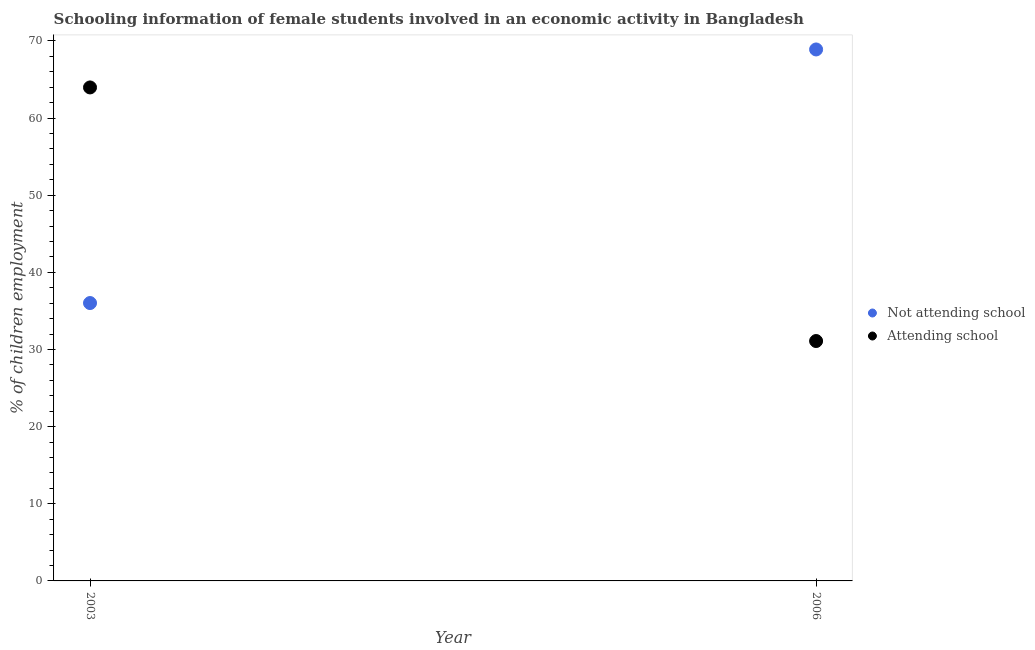How many different coloured dotlines are there?
Your answer should be very brief. 2. Is the number of dotlines equal to the number of legend labels?
Offer a terse response. Yes. What is the percentage of employed females who are not attending school in 2006?
Your answer should be compact. 68.9. Across all years, what is the maximum percentage of employed females who are not attending school?
Give a very brief answer. 68.9. Across all years, what is the minimum percentage of employed females who are not attending school?
Your answer should be compact. 36.02. In which year was the percentage of employed females who are not attending school minimum?
Make the answer very short. 2003. What is the total percentage of employed females who are not attending school in the graph?
Give a very brief answer. 104.92. What is the difference between the percentage of employed females who are not attending school in 2003 and that in 2006?
Provide a short and direct response. -32.88. What is the difference between the percentage of employed females who are not attending school in 2003 and the percentage of employed females who are attending school in 2006?
Your answer should be compact. 4.92. What is the average percentage of employed females who are attending school per year?
Provide a short and direct response. 47.54. In the year 2003, what is the difference between the percentage of employed females who are not attending school and percentage of employed females who are attending school?
Keep it short and to the point. -27.95. In how many years, is the percentage of employed females who are attending school greater than 26 %?
Ensure brevity in your answer.  2. What is the ratio of the percentage of employed females who are not attending school in 2003 to that in 2006?
Provide a short and direct response. 0.52. How many years are there in the graph?
Make the answer very short. 2. Does the graph contain grids?
Provide a succinct answer. No. What is the title of the graph?
Provide a succinct answer. Schooling information of female students involved in an economic activity in Bangladesh. What is the label or title of the Y-axis?
Ensure brevity in your answer.  % of children employment. What is the % of children employment in Not attending school in 2003?
Provide a succinct answer. 36.02. What is the % of children employment in Attending school in 2003?
Give a very brief answer. 63.98. What is the % of children employment in Not attending school in 2006?
Give a very brief answer. 68.9. What is the % of children employment of Attending school in 2006?
Provide a succinct answer. 31.1. Across all years, what is the maximum % of children employment of Not attending school?
Ensure brevity in your answer.  68.9. Across all years, what is the maximum % of children employment in Attending school?
Offer a very short reply. 63.98. Across all years, what is the minimum % of children employment in Not attending school?
Provide a short and direct response. 36.02. Across all years, what is the minimum % of children employment of Attending school?
Your answer should be compact. 31.1. What is the total % of children employment in Not attending school in the graph?
Give a very brief answer. 104.92. What is the total % of children employment in Attending school in the graph?
Provide a short and direct response. 95.08. What is the difference between the % of children employment of Not attending school in 2003 and that in 2006?
Your answer should be compact. -32.88. What is the difference between the % of children employment of Attending school in 2003 and that in 2006?
Ensure brevity in your answer.  32.88. What is the difference between the % of children employment of Not attending school in 2003 and the % of children employment of Attending school in 2006?
Ensure brevity in your answer.  4.92. What is the average % of children employment of Not attending school per year?
Provide a short and direct response. 52.46. What is the average % of children employment in Attending school per year?
Offer a terse response. 47.54. In the year 2003, what is the difference between the % of children employment of Not attending school and % of children employment of Attending school?
Provide a succinct answer. -27.95. In the year 2006, what is the difference between the % of children employment of Not attending school and % of children employment of Attending school?
Keep it short and to the point. 37.8. What is the ratio of the % of children employment of Not attending school in 2003 to that in 2006?
Your response must be concise. 0.52. What is the ratio of the % of children employment in Attending school in 2003 to that in 2006?
Your response must be concise. 2.06. What is the difference between the highest and the second highest % of children employment of Not attending school?
Keep it short and to the point. 32.88. What is the difference between the highest and the second highest % of children employment in Attending school?
Ensure brevity in your answer.  32.88. What is the difference between the highest and the lowest % of children employment in Not attending school?
Give a very brief answer. 32.88. What is the difference between the highest and the lowest % of children employment of Attending school?
Make the answer very short. 32.88. 